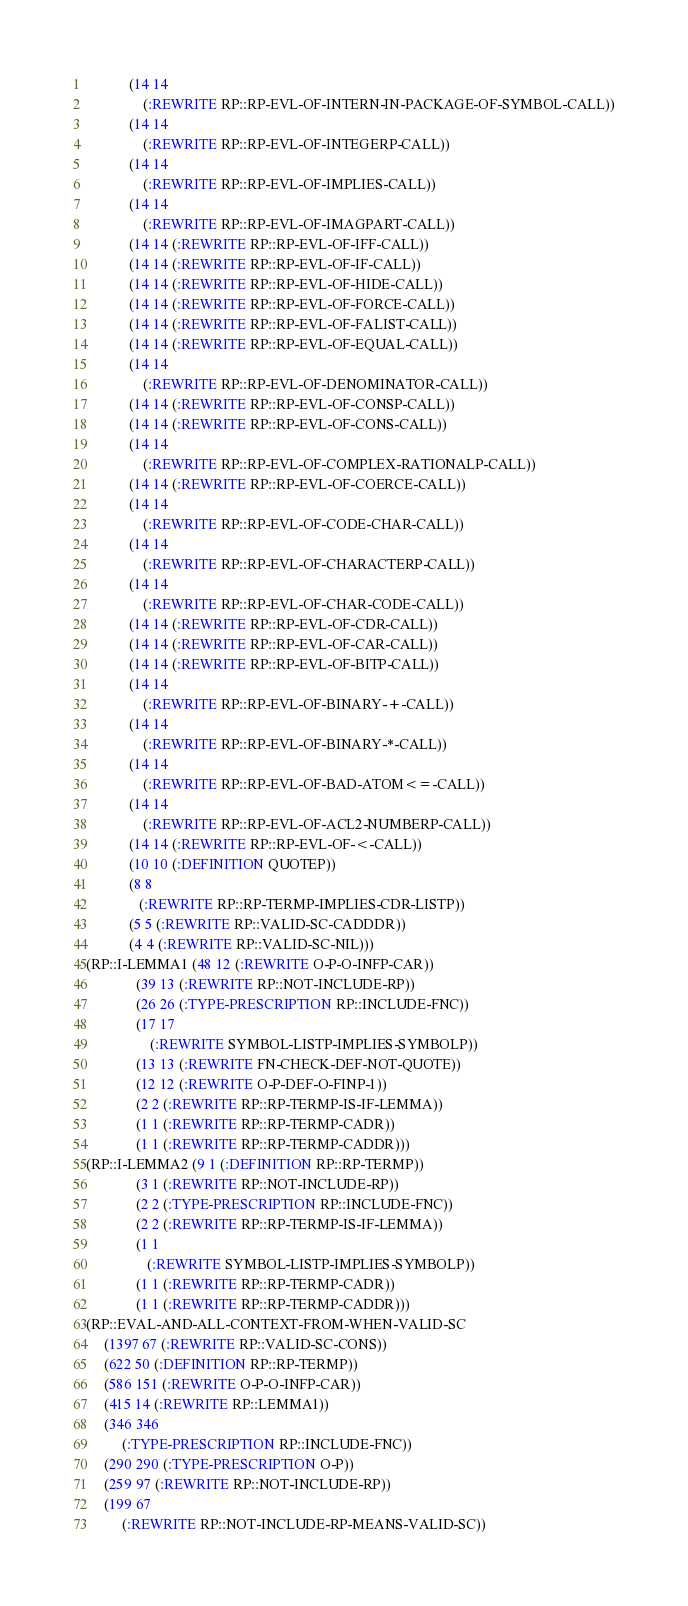<code> <loc_0><loc_0><loc_500><loc_500><_Lisp_>            (14 14
                (:REWRITE RP::RP-EVL-OF-INTERN-IN-PACKAGE-OF-SYMBOL-CALL))
            (14 14
                (:REWRITE RP::RP-EVL-OF-INTEGERP-CALL))
            (14 14
                (:REWRITE RP::RP-EVL-OF-IMPLIES-CALL))
            (14 14
                (:REWRITE RP::RP-EVL-OF-IMAGPART-CALL))
            (14 14 (:REWRITE RP::RP-EVL-OF-IFF-CALL))
            (14 14 (:REWRITE RP::RP-EVL-OF-IF-CALL))
            (14 14 (:REWRITE RP::RP-EVL-OF-HIDE-CALL))
            (14 14 (:REWRITE RP::RP-EVL-OF-FORCE-CALL))
            (14 14 (:REWRITE RP::RP-EVL-OF-FALIST-CALL))
            (14 14 (:REWRITE RP::RP-EVL-OF-EQUAL-CALL))
            (14 14
                (:REWRITE RP::RP-EVL-OF-DENOMINATOR-CALL))
            (14 14 (:REWRITE RP::RP-EVL-OF-CONSP-CALL))
            (14 14 (:REWRITE RP::RP-EVL-OF-CONS-CALL))
            (14 14
                (:REWRITE RP::RP-EVL-OF-COMPLEX-RATIONALP-CALL))
            (14 14 (:REWRITE RP::RP-EVL-OF-COERCE-CALL))
            (14 14
                (:REWRITE RP::RP-EVL-OF-CODE-CHAR-CALL))
            (14 14
                (:REWRITE RP::RP-EVL-OF-CHARACTERP-CALL))
            (14 14
                (:REWRITE RP::RP-EVL-OF-CHAR-CODE-CALL))
            (14 14 (:REWRITE RP::RP-EVL-OF-CDR-CALL))
            (14 14 (:REWRITE RP::RP-EVL-OF-CAR-CALL))
            (14 14 (:REWRITE RP::RP-EVL-OF-BITP-CALL))
            (14 14
                (:REWRITE RP::RP-EVL-OF-BINARY-+-CALL))
            (14 14
                (:REWRITE RP::RP-EVL-OF-BINARY-*-CALL))
            (14 14
                (:REWRITE RP::RP-EVL-OF-BAD-ATOM<=-CALL))
            (14 14
                (:REWRITE RP::RP-EVL-OF-ACL2-NUMBERP-CALL))
            (14 14 (:REWRITE RP::RP-EVL-OF-<-CALL))
            (10 10 (:DEFINITION QUOTEP))
            (8 8
               (:REWRITE RP::RP-TERMP-IMPLIES-CDR-LISTP))
            (5 5 (:REWRITE RP::VALID-SC-CADDDR))
            (4 4 (:REWRITE RP::VALID-SC-NIL)))
(RP::I-LEMMA1 (48 12 (:REWRITE O-P-O-INFP-CAR))
              (39 13 (:REWRITE RP::NOT-INCLUDE-RP))
              (26 26 (:TYPE-PRESCRIPTION RP::INCLUDE-FNC))
              (17 17
                  (:REWRITE SYMBOL-LISTP-IMPLIES-SYMBOLP))
              (13 13 (:REWRITE FN-CHECK-DEF-NOT-QUOTE))
              (12 12 (:REWRITE O-P-DEF-O-FINP-1))
              (2 2 (:REWRITE RP::RP-TERMP-IS-IF-LEMMA))
              (1 1 (:REWRITE RP::RP-TERMP-CADR))
              (1 1 (:REWRITE RP::RP-TERMP-CADDR)))
(RP::I-LEMMA2 (9 1 (:DEFINITION RP::RP-TERMP))
              (3 1 (:REWRITE RP::NOT-INCLUDE-RP))
              (2 2 (:TYPE-PRESCRIPTION RP::INCLUDE-FNC))
              (2 2 (:REWRITE RP::RP-TERMP-IS-IF-LEMMA))
              (1 1
                 (:REWRITE SYMBOL-LISTP-IMPLIES-SYMBOLP))
              (1 1 (:REWRITE RP::RP-TERMP-CADR))
              (1 1 (:REWRITE RP::RP-TERMP-CADDR)))
(RP::EVAL-AND-ALL-CONTEXT-FROM-WHEN-VALID-SC
     (1397 67 (:REWRITE RP::VALID-SC-CONS))
     (622 50 (:DEFINITION RP::RP-TERMP))
     (586 151 (:REWRITE O-P-O-INFP-CAR))
     (415 14 (:REWRITE RP::LEMMA1))
     (346 346
          (:TYPE-PRESCRIPTION RP::INCLUDE-FNC))
     (290 290 (:TYPE-PRESCRIPTION O-P))
     (259 97 (:REWRITE RP::NOT-INCLUDE-RP))
     (199 67
          (:REWRITE RP::NOT-INCLUDE-RP-MEANS-VALID-SC))</code> 